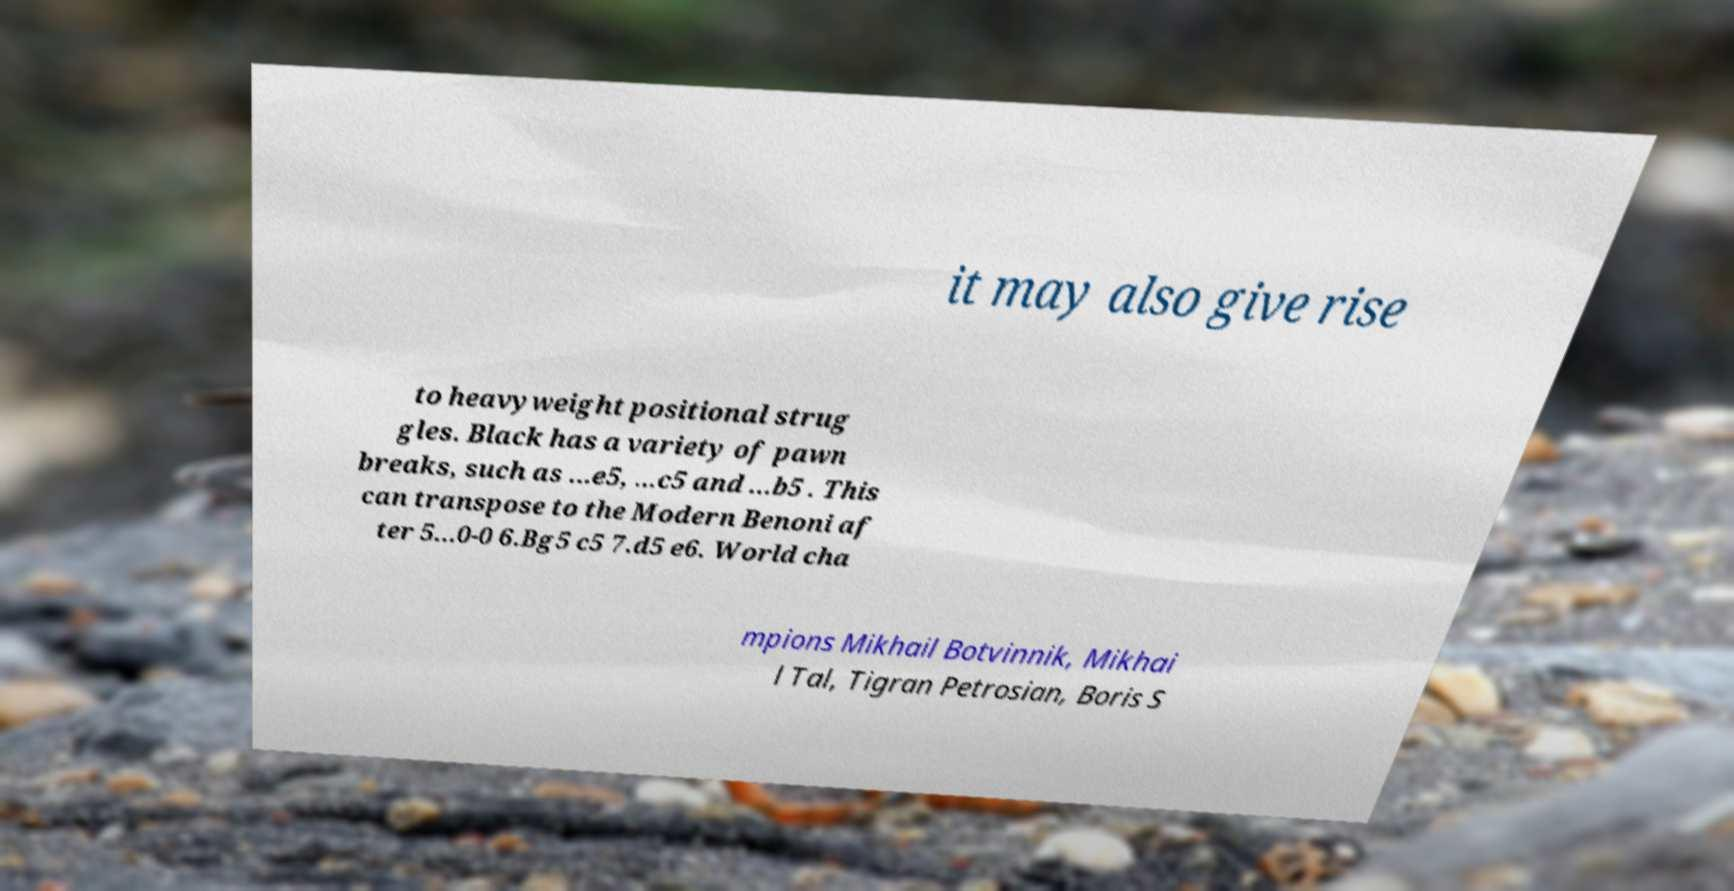For documentation purposes, I need the text within this image transcribed. Could you provide that? it may also give rise to heavyweight positional strug gles. Black has a variety of pawn breaks, such as ...e5, ...c5 and ...b5 . This can transpose to the Modern Benoni af ter 5...0-0 6.Bg5 c5 7.d5 e6. World cha mpions Mikhail Botvinnik, Mikhai l Tal, Tigran Petrosian, Boris S 